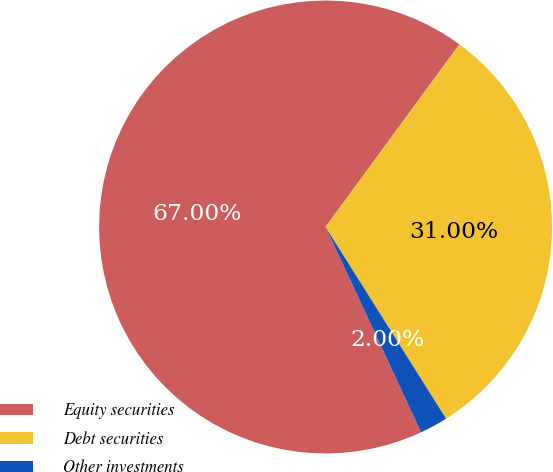Convert chart to OTSL. <chart><loc_0><loc_0><loc_500><loc_500><pie_chart><fcel>Equity securities<fcel>Debt securities<fcel>Other investments<nl><fcel>67.0%<fcel>31.0%<fcel>2.0%<nl></chart> 